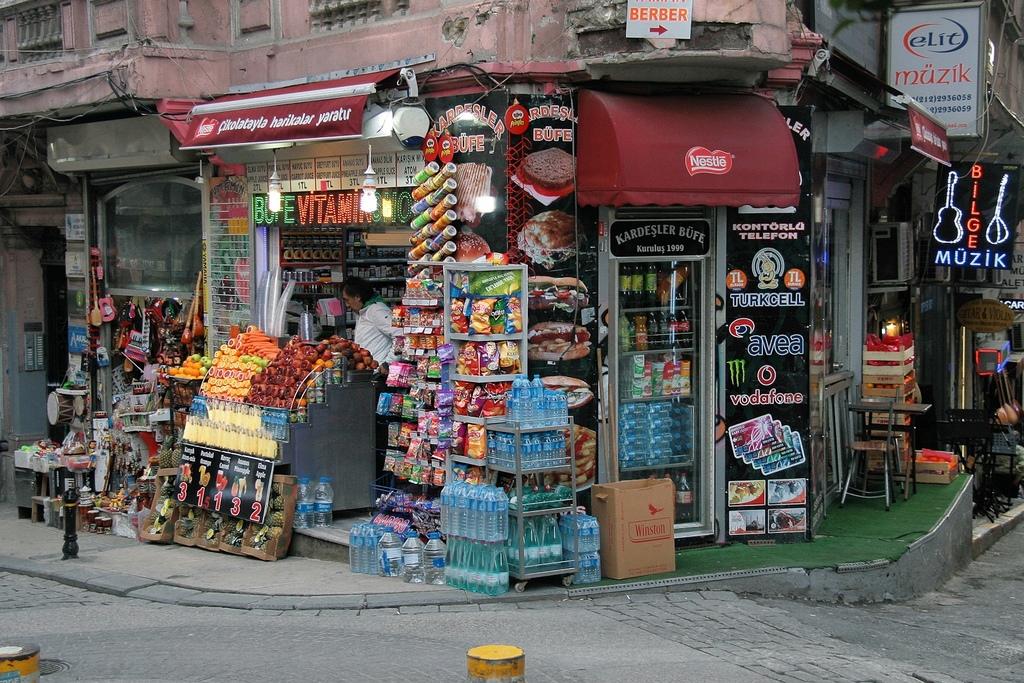What is the name of the store?
Offer a terse response. Kardesler bufe. What does it say in blue on the sign with the guitar on it?
Ensure brevity in your answer.  Muzik. 